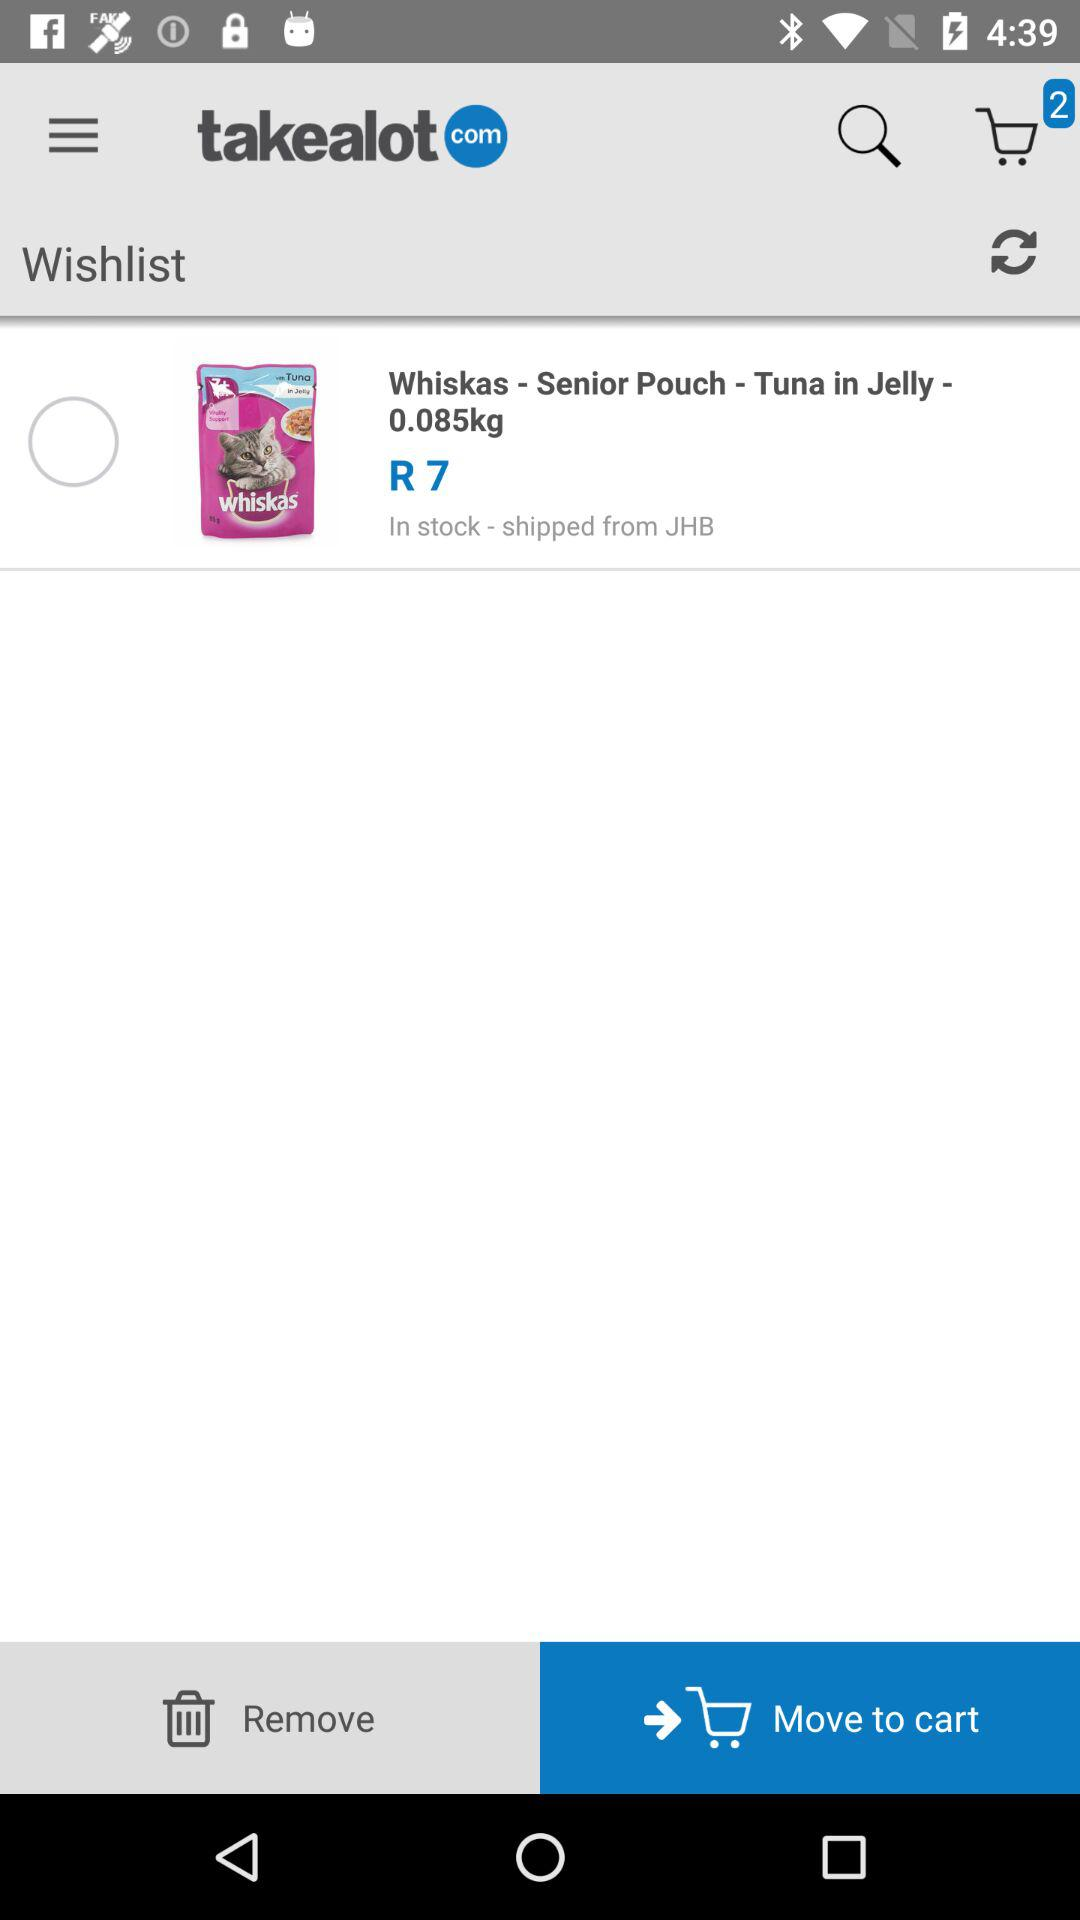How much do Whiskas weigh? Whiskas weigh 0.085 kg. 